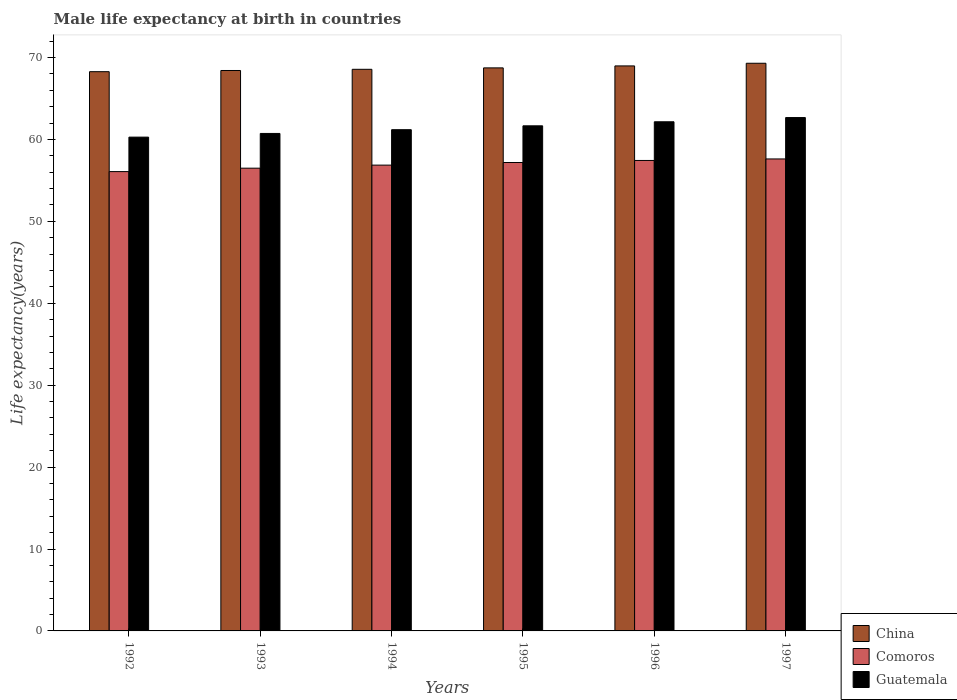How many different coloured bars are there?
Offer a terse response. 3. Are the number of bars per tick equal to the number of legend labels?
Make the answer very short. Yes. Are the number of bars on each tick of the X-axis equal?
Your response must be concise. Yes. How many bars are there on the 2nd tick from the left?
Give a very brief answer. 3. How many bars are there on the 2nd tick from the right?
Offer a very short reply. 3. What is the label of the 2nd group of bars from the left?
Your response must be concise. 1993. What is the male life expectancy at birth in China in 1996?
Give a very brief answer. 68.98. Across all years, what is the maximum male life expectancy at birth in China?
Provide a succinct answer. 69.3. Across all years, what is the minimum male life expectancy at birth in China?
Ensure brevity in your answer.  68.27. In which year was the male life expectancy at birth in Comoros minimum?
Your answer should be very brief. 1992. What is the total male life expectancy at birth in Guatemala in the graph?
Keep it short and to the point. 368.69. What is the difference between the male life expectancy at birth in Guatemala in 1995 and that in 1996?
Ensure brevity in your answer.  -0.49. What is the difference between the male life expectancy at birth in China in 1993 and the male life expectancy at birth in Comoros in 1996?
Offer a very short reply. 10.98. What is the average male life expectancy at birth in China per year?
Keep it short and to the point. 68.71. In the year 1997, what is the difference between the male life expectancy at birth in China and male life expectancy at birth in Comoros?
Ensure brevity in your answer.  11.68. In how many years, is the male life expectancy at birth in Comoros greater than 56 years?
Provide a succinct answer. 6. What is the ratio of the male life expectancy at birth in China in 1994 to that in 1997?
Give a very brief answer. 0.99. Is the male life expectancy at birth in China in 1993 less than that in 1995?
Your response must be concise. Yes. What is the difference between the highest and the second highest male life expectancy at birth in Guatemala?
Keep it short and to the point. 0.52. What is the difference between the highest and the lowest male life expectancy at birth in Guatemala?
Your response must be concise. 2.39. What does the 1st bar from the left in 1994 represents?
Your answer should be very brief. China. What does the 1st bar from the right in 1997 represents?
Your answer should be compact. Guatemala. How many bars are there?
Make the answer very short. 18. What is the difference between two consecutive major ticks on the Y-axis?
Give a very brief answer. 10. Does the graph contain any zero values?
Provide a succinct answer. No. Where does the legend appear in the graph?
Ensure brevity in your answer.  Bottom right. How are the legend labels stacked?
Provide a succinct answer. Vertical. What is the title of the graph?
Your answer should be very brief. Male life expectancy at birth in countries. What is the label or title of the X-axis?
Your answer should be very brief. Years. What is the label or title of the Y-axis?
Your response must be concise. Life expectancy(years). What is the Life expectancy(years) in China in 1992?
Offer a very short reply. 68.27. What is the Life expectancy(years) in Comoros in 1992?
Your answer should be very brief. 56.07. What is the Life expectancy(years) in Guatemala in 1992?
Your response must be concise. 60.28. What is the Life expectancy(years) in China in 1993?
Provide a succinct answer. 68.42. What is the Life expectancy(years) of Comoros in 1993?
Your answer should be very brief. 56.49. What is the Life expectancy(years) in Guatemala in 1993?
Your response must be concise. 60.73. What is the Life expectancy(years) of China in 1994?
Offer a very short reply. 68.56. What is the Life expectancy(years) of Comoros in 1994?
Provide a short and direct response. 56.87. What is the Life expectancy(years) in Guatemala in 1994?
Provide a short and direct response. 61.19. What is the Life expectancy(years) of China in 1995?
Provide a succinct answer. 68.74. What is the Life expectancy(years) of Comoros in 1995?
Your response must be concise. 57.18. What is the Life expectancy(years) in Guatemala in 1995?
Provide a succinct answer. 61.66. What is the Life expectancy(years) of China in 1996?
Your answer should be compact. 68.98. What is the Life expectancy(years) in Comoros in 1996?
Your answer should be compact. 57.43. What is the Life expectancy(years) of Guatemala in 1996?
Your answer should be very brief. 62.16. What is the Life expectancy(years) in China in 1997?
Ensure brevity in your answer.  69.3. What is the Life expectancy(years) of Comoros in 1997?
Make the answer very short. 57.62. What is the Life expectancy(years) in Guatemala in 1997?
Your response must be concise. 62.67. Across all years, what is the maximum Life expectancy(years) of China?
Make the answer very short. 69.3. Across all years, what is the maximum Life expectancy(years) in Comoros?
Offer a terse response. 57.62. Across all years, what is the maximum Life expectancy(years) of Guatemala?
Your response must be concise. 62.67. Across all years, what is the minimum Life expectancy(years) of China?
Your response must be concise. 68.27. Across all years, what is the minimum Life expectancy(years) of Comoros?
Your response must be concise. 56.07. Across all years, what is the minimum Life expectancy(years) in Guatemala?
Offer a terse response. 60.28. What is the total Life expectancy(years) in China in the graph?
Give a very brief answer. 412.26. What is the total Life expectancy(years) of Comoros in the graph?
Your response must be concise. 341.67. What is the total Life expectancy(years) in Guatemala in the graph?
Provide a succinct answer. 368.69. What is the difference between the Life expectancy(years) of China in 1992 and that in 1993?
Give a very brief answer. -0.14. What is the difference between the Life expectancy(years) in Comoros in 1992 and that in 1993?
Make the answer very short. -0.42. What is the difference between the Life expectancy(years) in Guatemala in 1992 and that in 1993?
Make the answer very short. -0.45. What is the difference between the Life expectancy(years) of China in 1992 and that in 1994?
Your answer should be very brief. -0.29. What is the difference between the Life expectancy(years) in Comoros in 1992 and that in 1994?
Offer a terse response. -0.79. What is the difference between the Life expectancy(years) of Guatemala in 1992 and that in 1994?
Offer a terse response. -0.91. What is the difference between the Life expectancy(years) in China in 1992 and that in 1995?
Your response must be concise. -0.46. What is the difference between the Life expectancy(years) of Comoros in 1992 and that in 1995?
Offer a very short reply. -1.11. What is the difference between the Life expectancy(years) in Guatemala in 1992 and that in 1995?
Offer a terse response. -1.38. What is the difference between the Life expectancy(years) in China in 1992 and that in 1996?
Your answer should be very brief. -0.7. What is the difference between the Life expectancy(years) in Comoros in 1992 and that in 1996?
Offer a very short reply. -1.36. What is the difference between the Life expectancy(years) of Guatemala in 1992 and that in 1996?
Your response must be concise. -1.87. What is the difference between the Life expectancy(years) of China in 1992 and that in 1997?
Keep it short and to the point. -1.03. What is the difference between the Life expectancy(years) of Comoros in 1992 and that in 1997?
Your response must be concise. -1.55. What is the difference between the Life expectancy(years) of Guatemala in 1992 and that in 1997?
Keep it short and to the point. -2.39. What is the difference between the Life expectancy(years) in China in 1993 and that in 1994?
Make the answer very short. -0.14. What is the difference between the Life expectancy(years) in Comoros in 1993 and that in 1994?
Make the answer very short. -0.37. What is the difference between the Life expectancy(years) of Guatemala in 1993 and that in 1994?
Offer a very short reply. -0.46. What is the difference between the Life expectancy(years) in China in 1993 and that in 1995?
Offer a terse response. -0.32. What is the difference between the Life expectancy(years) of Comoros in 1993 and that in 1995?
Your response must be concise. -0.69. What is the difference between the Life expectancy(years) in Guatemala in 1993 and that in 1995?
Provide a short and direct response. -0.93. What is the difference between the Life expectancy(years) of China in 1993 and that in 1996?
Your response must be concise. -0.56. What is the difference between the Life expectancy(years) of Comoros in 1993 and that in 1996?
Ensure brevity in your answer.  -0.94. What is the difference between the Life expectancy(years) of Guatemala in 1993 and that in 1996?
Your answer should be compact. -1.42. What is the difference between the Life expectancy(years) in China in 1993 and that in 1997?
Keep it short and to the point. -0.88. What is the difference between the Life expectancy(years) in Comoros in 1993 and that in 1997?
Give a very brief answer. -1.13. What is the difference between the Life expectancy(years) in Guatemala in 1993 and that in 1997?
Your response must be concise. -1.94. What is the difference between the Life expectancy(years) of China in 1994 and that in 1995?
Your response must be concise. -0.17. What is the difference between the Life expectancy(years) of Comoros in 1994 and that in 1995?
Your response must be concise. -0.32. What is the difference between the Life expectancy(years) in Guatemala in 1994 and that in 1995?
Your answer should be very brief. -0.47. What is the difference between the Life expectancy(years) in China in 1994 and that in 1996?
Offer a terse response. -0.41. What is the difference between the Life expectancy(years) of Comoros in 1994 and that in 1996?
Keep it short and to the point. -0.57. What is the difference between the Life expectancy(years) of Guatemala in 1994 and that in 1996?
Provide a short and direct response. -0.97. What is the difference between the Life expectancy(years) in China in 1994 and that in 1997?
Your answer should be compact. -0.74. What is the difference between the Life expectancy(years) in Comoros in 1994 and that in 1997?
Provide a succinct answer. -0.75. What is the difference between the Life expectancy(years) of Guatemala in 1994 and that in 1997?
Make the answer very short. -1.48. What is the difference between the Life expectancy(years) of China in 1995 and that in 1996?
Your answer should be compact. -0.24. What is the difference between the Life expectancy(years) in Guatemala in 1995 and that in 1996?
Ensure brevity in your answer.  -0.49. What is the difference between the Life expectancy(years) of China in 1995 and that in 1997?
Provide a succinct answer. -0.56. What is the difference between the Life expectancy(years) of Comoros in 1995 and that in 1997?
Offer a very short reply. -0.43. What is the difference between the Life expectancy(years) of Guatemala in 1995 and that in 1997?
Offer a terse response. -1.01. What is the difference between the Life expectancy(years) of China in 1996 and that in 1997?
Make the answer very short. -0.32. What is the difference between the Life expectancy(years) of Comoros in 1996 and that in 1997?
Offer a terse response. -0.18. What is the difference between the Life expectancy(years) in Guatemala in 1996 and that in 1997?
Your answer should be compact. -0.52. What is the difference between the Life expectancy(years) of China in 1992 and the Life expectancy(years) of Comoros in 1993?
Your response must be concise. 11.78. What is the difference between the Life expectancy(years) in China in 1992 and the Life expectancy(years) in Guatemala in 1993?
Offer a terse response. 7.54. What is the difference between the Life expectancy(years) in Comoros in 1992 and the Life expectancy(years) in Guatemala in 1993?
Keep it short and to the point. -4.66. What is the difference between the Life expectancy(years) in China in 1992 and the Life expectancy(years) in Comoros in 1994?
Keep it short and to the point. 11.41. What is the difference between the Life expectancy(years) in China in 1992 and the Life expectancy(years) in Guatemala in 1994?
Your answer should be very brief. 7.08. What is the difference between the Life expectancy(years) in Comoros in 1992 and the Life expectancy(years) in Guatemala in 1994?
Provide a succinct answer. -5.12. What is the difference between the Life expectancy(years) in China in 1992 and the Life expectancy(years) in Comoros in 1995?
Give a very brief answer. 11.09. What is the difference between the Life expectancy(years) of China in 1992 and the Life expectancy(years) of Guatemala in 1995?
Offer a very short reply. 6.61. What is the difference between the Life expectancy(years) of Comoros in 1992 and the Life expectancy(years) of Guatemala in 1995?
Offer a terse response. -5.59. What is the difference between the Life expectancy(years) in China in 1992 and the Life expectancy(years) in Comoros in 1996?
Provide a succinct answer. 10.84. What is the difference between the Life expectancy(years) of China in 1992 and the Life expectancy(years) of Guatemala in 1996?
Your answer should be compact. 6.12. What is the difference between the Life expectancy(years) in Comoros in 1992 and the Life expectancy(years) in Guatemala in 1996?
Your response must be concise. -6.08. What is the difference between the Life expectancy(years) of China in 1992 and the Life expectancy(years) of Comoros in 1997?
Your answer should be compact. 10.65. What is the difference between the Life expectancy(years) in Comoros in 1992 and the Life expectancy(years) in Guatemala in 1997?
Offer a terse response. -6.6. What is the difference between the Life expectancy(years) of China in 1993 and the Life expectancy(years) of Comoros in 1994?
Keep it short and to the point. 11.55. What is the difference between the Life expectancy(years) in China in 1993 and the Life expectancy(years) in Guatemala in 1994?
Offer a very short reply. 7.23. What is the difference between the Life expectancy(years) in Comoros in 1993 and the Life expectancy(years) in Guatemala in 1994?
Provide a short and direct response. -4.7. What is the difference between the Life expectancy(years) of China in 1993 and the Life expectancy(years) of Comoros in 1995?
Give a very brief answer. 11.23. What is the difference between the Life expectancy(years) in China in 1993 and the Life expectancy(years) in Guatemala in 1995?
Provide a short and direct response. 6.75. What is the difference between the Life expectancy(years) in Comoros in 1993 and the Life expectancy(years) in Guatemala in 1995?
Keep it short and to the point. -5.17. What is the difference between the Life expectancy(years) of China in 1993 and the Life expectancy(years) of Comoros in 1996?
Ensure brevity in your answer.  10.98. What is the difference between the Life expectancy(years) of China in 1993 and the Life expectancy(years) of Guatemala in 1996?
Ensure brevity in your answer.  6.26. What is the difference between the Life expectancy(years) in Comoros in 1993 and the Life expectancy(years) in Guatemala in 1996?
Your answer should be very brief. -5.66. What is the difference between the Life expectancy(years) in China in 1993 and the Life expectancy(years) in Comoros in 1997?
Your answer should be compact. 10.8. What is the difference between the Life expectancy(years) of China in 1993 and the Life expectancy(years) of Guatemala in 1997?
Give a very brief answer. 5.75. What is the difference between the Life expectancy(years) in Comoros in 1993 and the Life expectancy(years) in Guatemala in 1997?
Provide a succinct answer. -6.18. What is the difference between the Life expectancy(years) in China in 1994 and the Life expectancy(years) in Comoros in 1995?
Offer a terse response. 11.38. What is the difference between the Life expectancy(years) of China in 1994 and the Life expectancy(years) of Guatemala in 1995?
Offer a very short reply. 6.9. What is the difference between the Life expectancy(years) of Comoros in 1994 and the Life expectancy(years) of Guatemala in 1995?
Your response must be concise. -4.8. What is the difference between the Life expectancy(years) of China in 1994 and the Life expectancy(years) of Comoros in 1996?
Your response must be concise. 11.13. What is the difference between the Life expectancy(years) of China in 1994 and the Life expectancy(years) of Guatemala in 1996?
Keep it short and to the point. 6.41. What is the difference between the Life expectancy(years) in Comoros in 1994 and the Life expectancy(years) in Guatemala in 1996?
Make the answer very short. -5.29. What is the difference between the Life expectancy(years) in China in 1994 and the Life expectancy(years) in Comoros in 1997?
Keep it short and to the point. 10.94. What is the difference between the Life expectancy(years) of China in 1994 and the Life expectancy(years) of Guatemala in 1997?
Your response must be concise. 5.89. What is the difference between the Life expectancy(years) of Comoros in 1994 and the Life expectancy(years) of Guatemala in 1997?
Make the answer very short. -5.81. What is the difference between the Life expectancy(years) in China in 1995 and the Life expectancy(years) in Comoros in 1996?
Keep it short and to the point. 11.3. What is the difference between the Life expectancy(years) of China in 1995 and the Life expectancy(years) of Guatemala in 1996?
Give a very brief answer. 6.58. What is the difference between the Life expectancy(years) in Comoros in 1995 and the Life expectancy(years) in Guatemala in 1996?
Your response must be concise. -4.97. What is the difference between the Life expectancy(years) in China in 1995 and the Life expectancy(years) in Comoros in 1997?
Give a very brief answer. 11.12. What is the difference between the Life expectancy(years) of China in 1995 and the Life expectancy(years) of Guatemala in 1997?
Ensure brevity in your answer.  6.06. What is the difference between the Life expectancy(years) in Comoros in 1995 and the Life expectancy(years) in Guatemala in 1997?
Ensure brevity in your answer.  -5.49. What is the difference between the Life expectancy(years) of China in 1996 and the Life expectancy(years) of Comoros in 1997?
Provide a short and direct response. 11.36. What is the difference between the Life expectancy(years) in China in 1996 and the Life expectancy(years) in Guatemala in 1997?
Provide a short and direct response. 6.3. What is the difference between the Life expectancy(years) of Comoros in 1996 and the Life expectancy(years) of Guatemala in 1997?
Offer a terse response. -5.24. What is the average Life expectancy(years) of China per year?
Your answer should be compact. 68.71. What is the average Life expectancy(years) in Comoros per year?
Give a very brief answer. 56.94. What is the average Life expectancy(years) in Guatemala per year?
Make the answer very short. 61.45. In the year 1992, what is the difference between the Life expectancy(years) of China and Life expectancy(years) of Comoros?
Give a very brief answer. 12.2. In the year 1992, what is the difference between the Life expectancy(years) of China and Life expectancy(years) of Guatemala?
Provide a succinct answer. 7.99. In the year 1992, what is the difference between the Life expectancy(years) of Comoros and Life expectancy(years) of Guatemala?
Provide a short and direct response. -4.21. In the year 1993, what is the difference between the Life expectancy(years) of China and Life expectancy(years) of Comoros?
Your response must be concise. 11.93. In the year 1993, what is the difference between the Life expectancy(years) of China and Life expectancy(years) of Guatemala?
Keep it short and to the point. 7.68. In the year 1993, what is the difference between the Life expectancy(years) of Comoros and Life expectancy(years) of Guatemala?
Give a very brief answer. -4.24. In the year 1994, what is the difference between the Life expectancy(years) in China and Life expectancy(years) in Comoros?
Offer a terse response. 11.7. In the year 1994, what is the difference between the Life expectancy(years) of China and Life expectancy(years) of Guatemala?
Keep it short and to the point. 7.37. In the year 1994, what is the difference between the Life expectancy(years) in Comoros and Life expectancy(years) in Guatemala?
Your answer should be compact. -4.32. In the year 1995, what is the difference between the Life expectancy(years) of China and Life expectancy(years) of Comoros?
Your answer should be compact. 11.55. In the year 1995, what is the difference between the Life expectancy(years) of China and Life expectancy(years) of Guatemala?
Your response must be concise. 7.07. In the year 1995, what is the difference between the Life expectancy(years) in Comoros and Life expectancy(years) in Guatemala?
Offer a terse response. -4.48. In the year 1996, what is the difference between the Life expectancy(years) in China and Life expectancy(years) in Comoros?
Ensure brevity in your answer.  11.54. In the year 1996, what is the difference between the Life expectancy(years) in China and Life expectancy(years) in Guatemala?
Offer a terse response. 6.82. In the year 1996, what is the difference between the Life expectancy(years) of Comoros and Life expectancy(years) of Guatemala?
Offer a very short reply. -4.72. In the year 1997, what is the difference between the Life expectancy(years) of China and Life expectancy(years) of Comoros?
Your response must be concise. 11.68. In the year 1997, what is the difference between the Life expectancy(years) of China and Life expectancy(years) of Guatemala?
Offer a very short reply. 6.63. In the year 1997, what is the difference between the Life expectancy(years) of Comoros and Life expectancy(years) of Guatemala?
Your answer should be compact. -5.05. What is the ratio of the Life expectancy(years) of China in 1992 to that in 1993?
Provide a short and direct response. 1. What is the ratio of the Life expectancy(years) in China in 1992 to that in 1994?
Give a very brief answer. 1. What is the ratio of the Life expectancy(years) of Comoros in 1992 to that in 1994?
Give a very brief answer. 0.99. What is the ratio of the Life expectancy(years) of Guatemala in 1992 to that in 1994?
Offer a very short reply. 0.99. What is the ratio of the Life expectancy(years) in China in 1992 to that in 1995?
Offer a very short reply. 0.99. What is the ratio of the Life expectancy(years) in Comoros in 1992 to that in 1995?
Your answer should be compact. 0.98. What is the ratio of the Life expectancy(years) in Guatemala in 1992 to that in 1995?
Offer a terse response. 0.98. What is the ratio of the Life expectancy(years) of China in 1992 to that in 1996?
Provide a succinct answer. 0.99. What is the ratio of the Life expectancy(years) in Comoros in 1992 to that in 1996?
Your answer should be very brief. 0.98. What is the ratio of the Life expectancy(years) in Guatemala in 1992 to that in 1996?
Your answer should be very brief. 0.97. What is the ratio of the Life expectancy(years) of China in 1992 to that in 1997?
Keep it short and to the point. 0.99. What is the ratio of the Life expectancy(years) of Comoros in 1992 to that in 1997?
Provide a short and direct response. 0.97. What is the ratio of the Life expectancy(years) in Guatemala in 1992 to that in 1997?
Your answer should be very brief. 0.96. What is the ratio of the Life expectancy(years) of China in 1993 to that in 1994?
Make the answer very short. 1. What is the ratio of the Life expectancy(years) of Comoros in 1993 to that in 1994?
Provide a short and direct response. 0.99. What is the ratio of the Life expectancy(years) of Comoros in 1993 to that in 1995?
Your answer should be compact. 0.99. What is the ratio of the Life expectancy(years) in Guatemala in 1993 to that in 1995?
Offer a terse response. 0.98. What is the ratio of the Life expectancy(years) of Comoros in 1993 to that in 1996?
Ensure brevity in your answer.  0.98. What is the ratio of the Life expectancy(years) in Guatemala in 1993 to that in 1996?
Your answer should be compact. 0.98. What is the ratio of the Life expectancy(years) of China in 1993 to that in 1997?
Make the answer very short. 0.99. What is the ratio of the Life expectancy(years) of Comoros in 1993 to that in 1997?
Provide a short and direct response. 0.98. What is the ratio of the Life expectancy(years) in Guatemala in 1994 to that in 1995?
Your answer should be compact. 0.99. What is the ratio of the Life expectancy(years) of Comoros in 1994 to that in 1996?
Offer a terse response. 0.99. What is the ratio of the Life expectancy(years) of Guatemala in 1994 to that in 1996?
Provide a succinct answer. 0.98. What is the ratio of the Life expectancy(years) in China in 1994 to that in 1997?
Your response must be concise. 0.99. What is the ratio of the Life expectancy(years) of Comoros in 1994 to that in 1997?
Keep it short and to the point. 0.99. What is the ratio of the Life expectancy(years) of Guatemala in 1994 to that in 1997?
Give a very brief answer. 0.98. What is the ratio of the Life expectancy(years) in China in 1995 to that in 1996?
Offer a very short reply. 1. What is the ratio of the Life expectancy(years) of Comoros in 1995 to that in 1996?
Give a very brief answer. 1. What is the ratio of the Life expectancy(years) in Guatemala in 1995 to that in 1997?
Keep it short and to the point. 0.98. What is the ratio of the Life expectancy(years) of China in 1996 to that in 1997?
Keep it short and to the point. 1. What is the ratio of the Life expectancy(years) in Comoros in 1996 to that in 1997?
Provide a short and direct response. 1. What is the ratio of the Life expectancy(years) of Guatemala in 1996 to that in 1997?
Offer a terse response. 0.99. What is the difference between the highest and the second highest Life expectancy(years) in China?
Provide a succinct answer. 0.32. What is the difference between the highest and the second highest Life expectancy(years) of Comoros?
Keep it short and to the point. 0.18. What is the difference between the highest and the second highest Life expectancy(years) of Guatemala?
Your response must be concise. 0.52. What is the difference between the highest and the lowest Life expectancy(years) of China?
Your response must be concise. 1.03. What is the difference between the highest and the lowest Life expectancy(years) in Comoros?
Your answer should be compact. 1.55. What is the difference between the highest and the lowest Life expectancy(years) in Guatemala?
Your response must be concise. 2.39. 